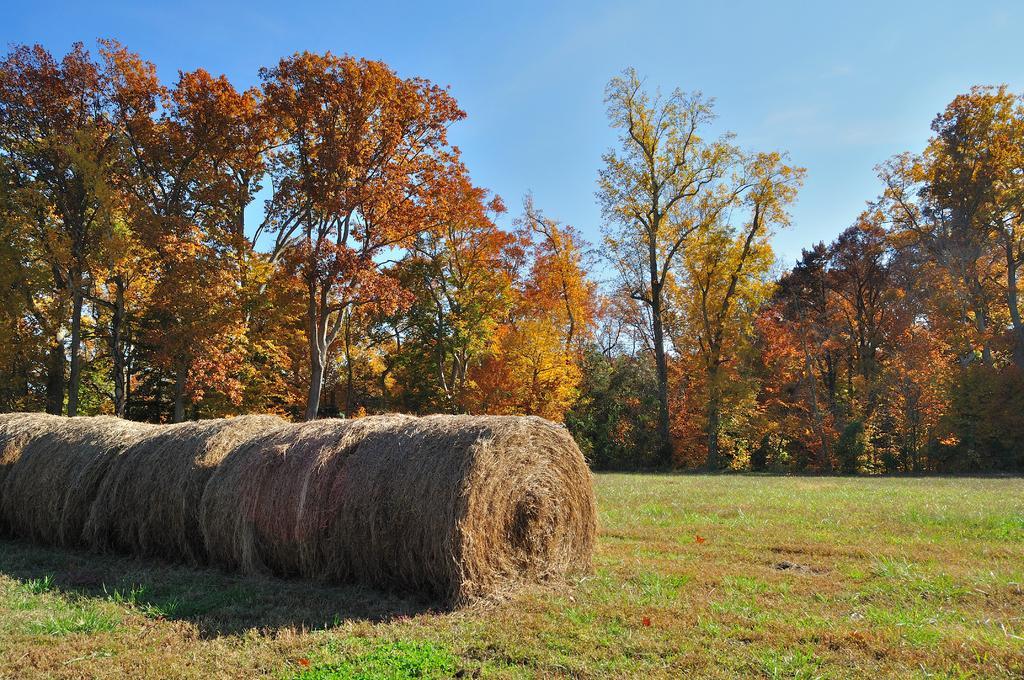In one or two sentences, can you explain what this image depicts? In this image there is hay. In the background there are trees and sky. At the bottom there is grass. 